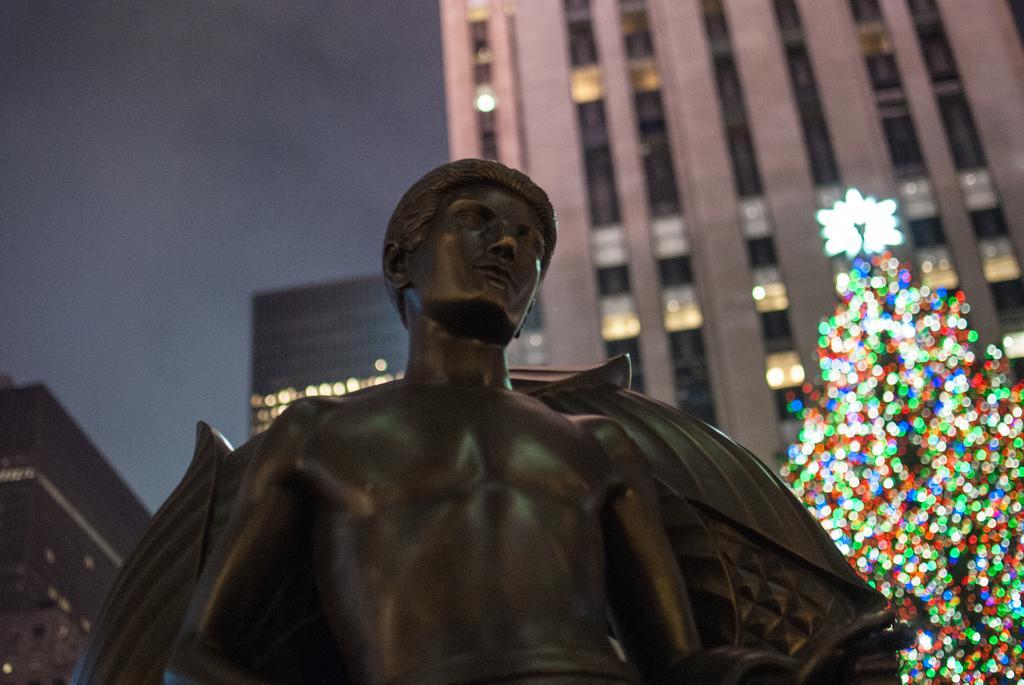Could you give a brief overview of what you see in this image? In this image we can see a statue. On the backside we can see a tree with some decorative lights, some buildings and the sky. 